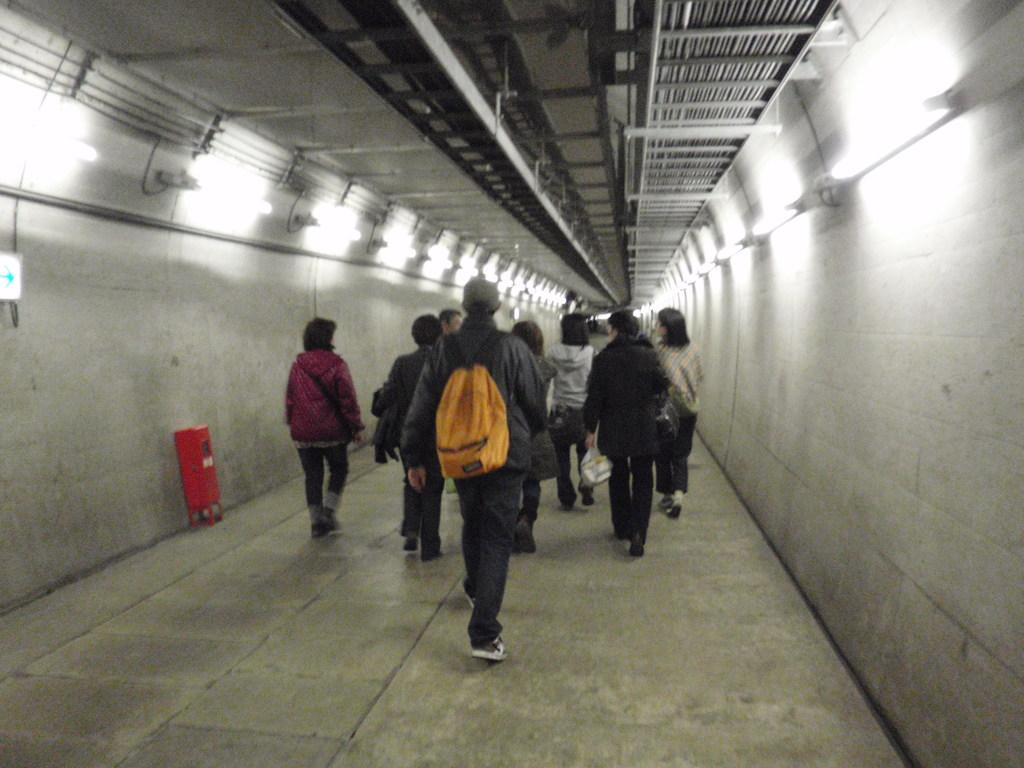What are the people in the image doing? The people in the image are walking inside the tunnel. What feature of the tunnel is mentioned in the facts? There are lights attached to the tunnel. What type of table can be seen in the image? There is no table present in the image; it features people walking inside a tunnel with lights attached. What kind of beast is lurking in the shadows of the tunnel? There is no mention of a beast in the image or the provided facts. 